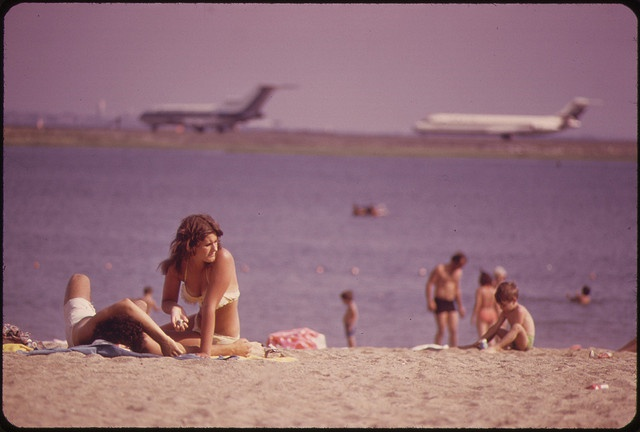Describe the objects in this image and their specific colors. I can see people in black, maroon, brown, tan, and salmon tones, people in black, maroon, brown, and tan tones, airplane in black, darkgray, and gray tones, airplane in black, purple, and gray tones, and people in black, brown, and maroon tones in this image. 